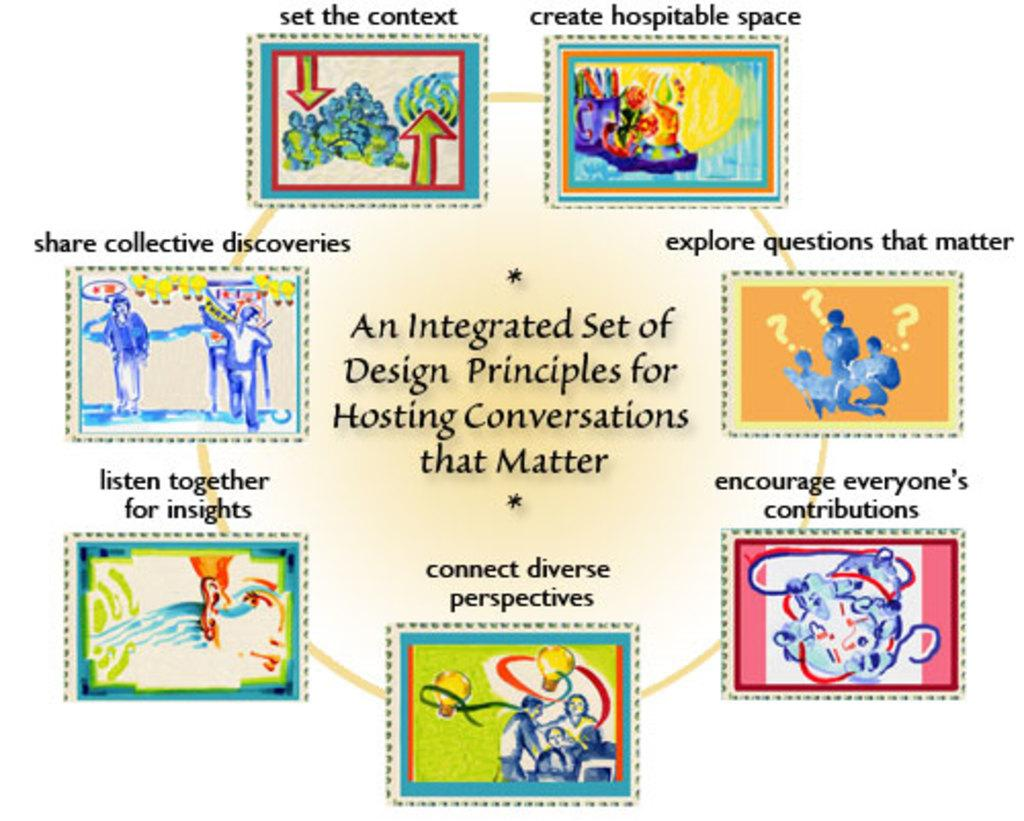<image>
Give a short and clear explanation of the subsequent image. A poster illustrates a set of principles underlying worthwhile conversations. 